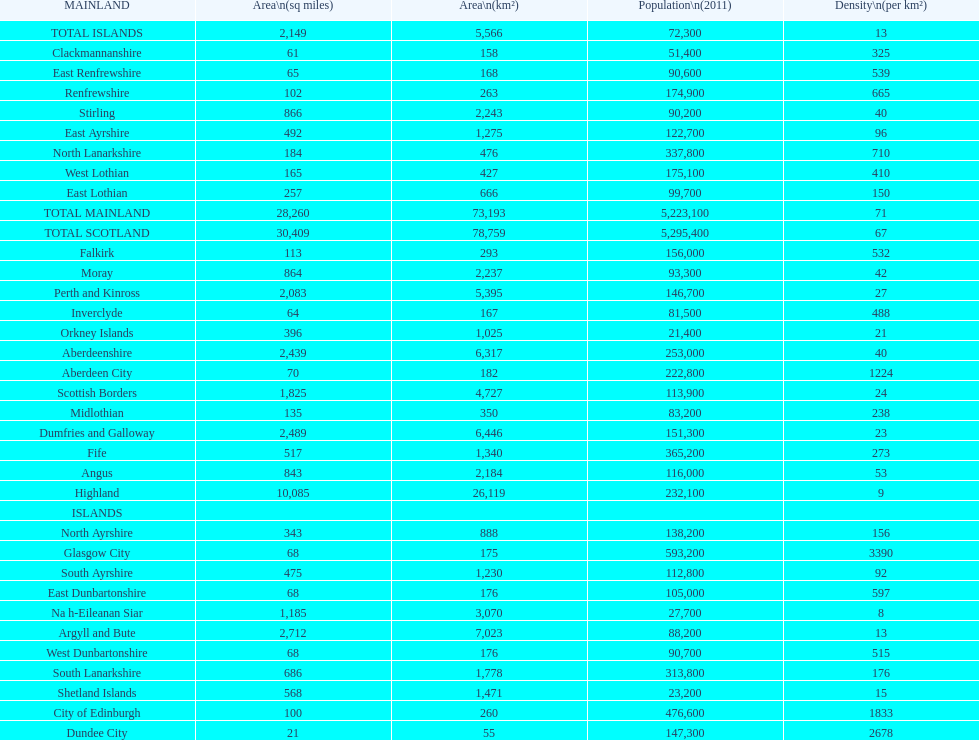What number of mainlands have populations under 100,000? 9. 